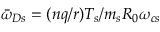<formula> <loc_0><loc_0><loc_500><loc_500>{ \bar { \omega } } _ { D s } = ( n q / r ) T _ { s } / m _ { s } R _ { 0 } \omega _ { c s }</formula> 